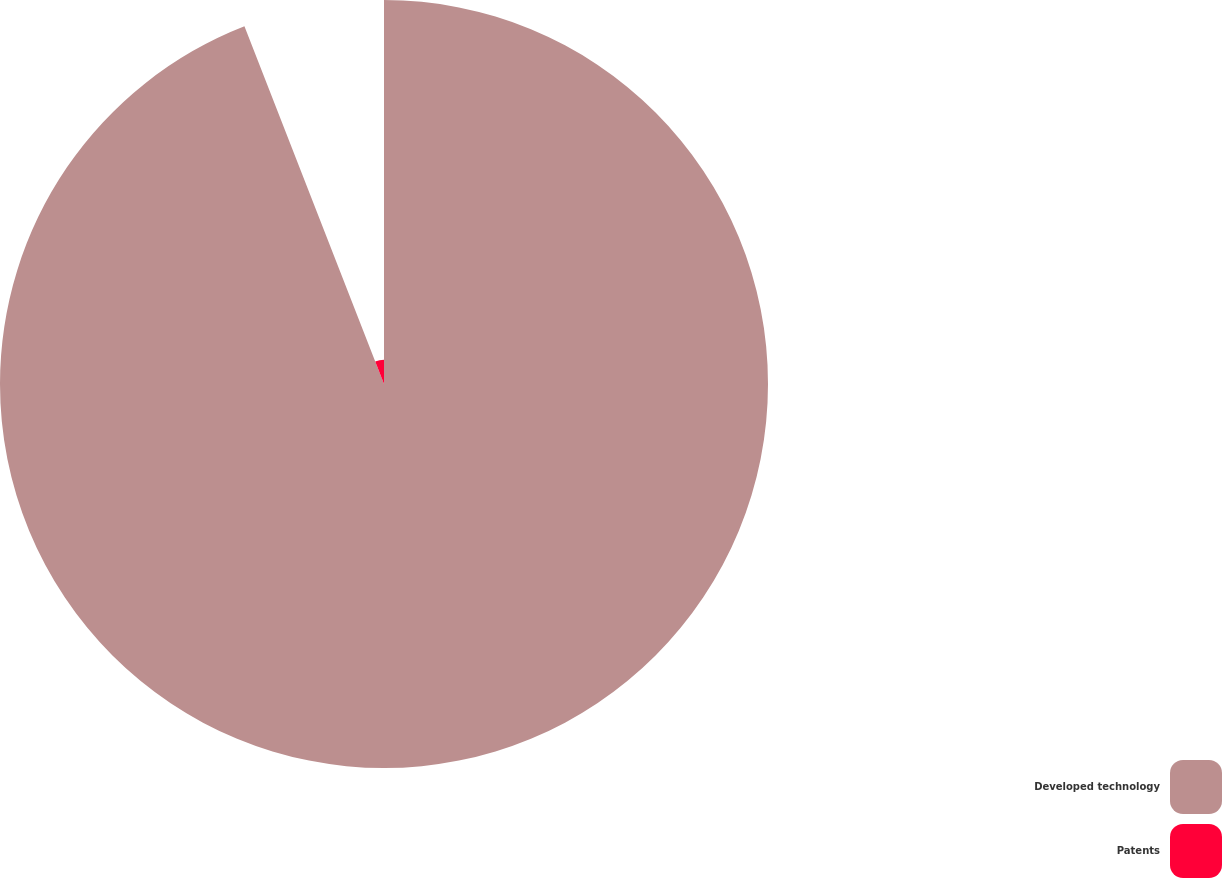Convert chart to OTSL. <chart><loc_0><loc_0><loc_500><loc_500><pie_chart><fcel>Developed technology<fcel>Patents<nl><fcel>94.08%<fcel>5.92%<nl></chart> 